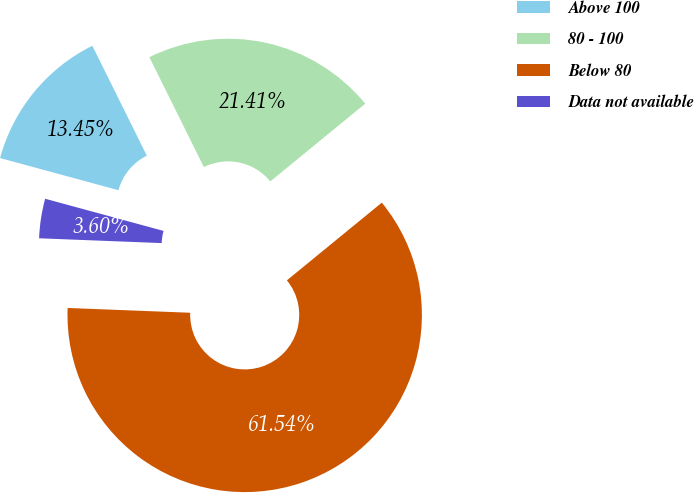<chart> <loc_0><loc_0><loc_500><loc_500><pie_chart><fcel>Above 100<fcel>80 - 100<fcel>Below 80<fcel>Data not available<nl><fcel>13.45%<fcel>21.41%<fcel>61.54%<fcel>3.6%<nl></chart> 